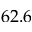Convert formula to latex. <formula><loc_0><loc_0><loc_500><loc_500>6 2 . 6</formula> 